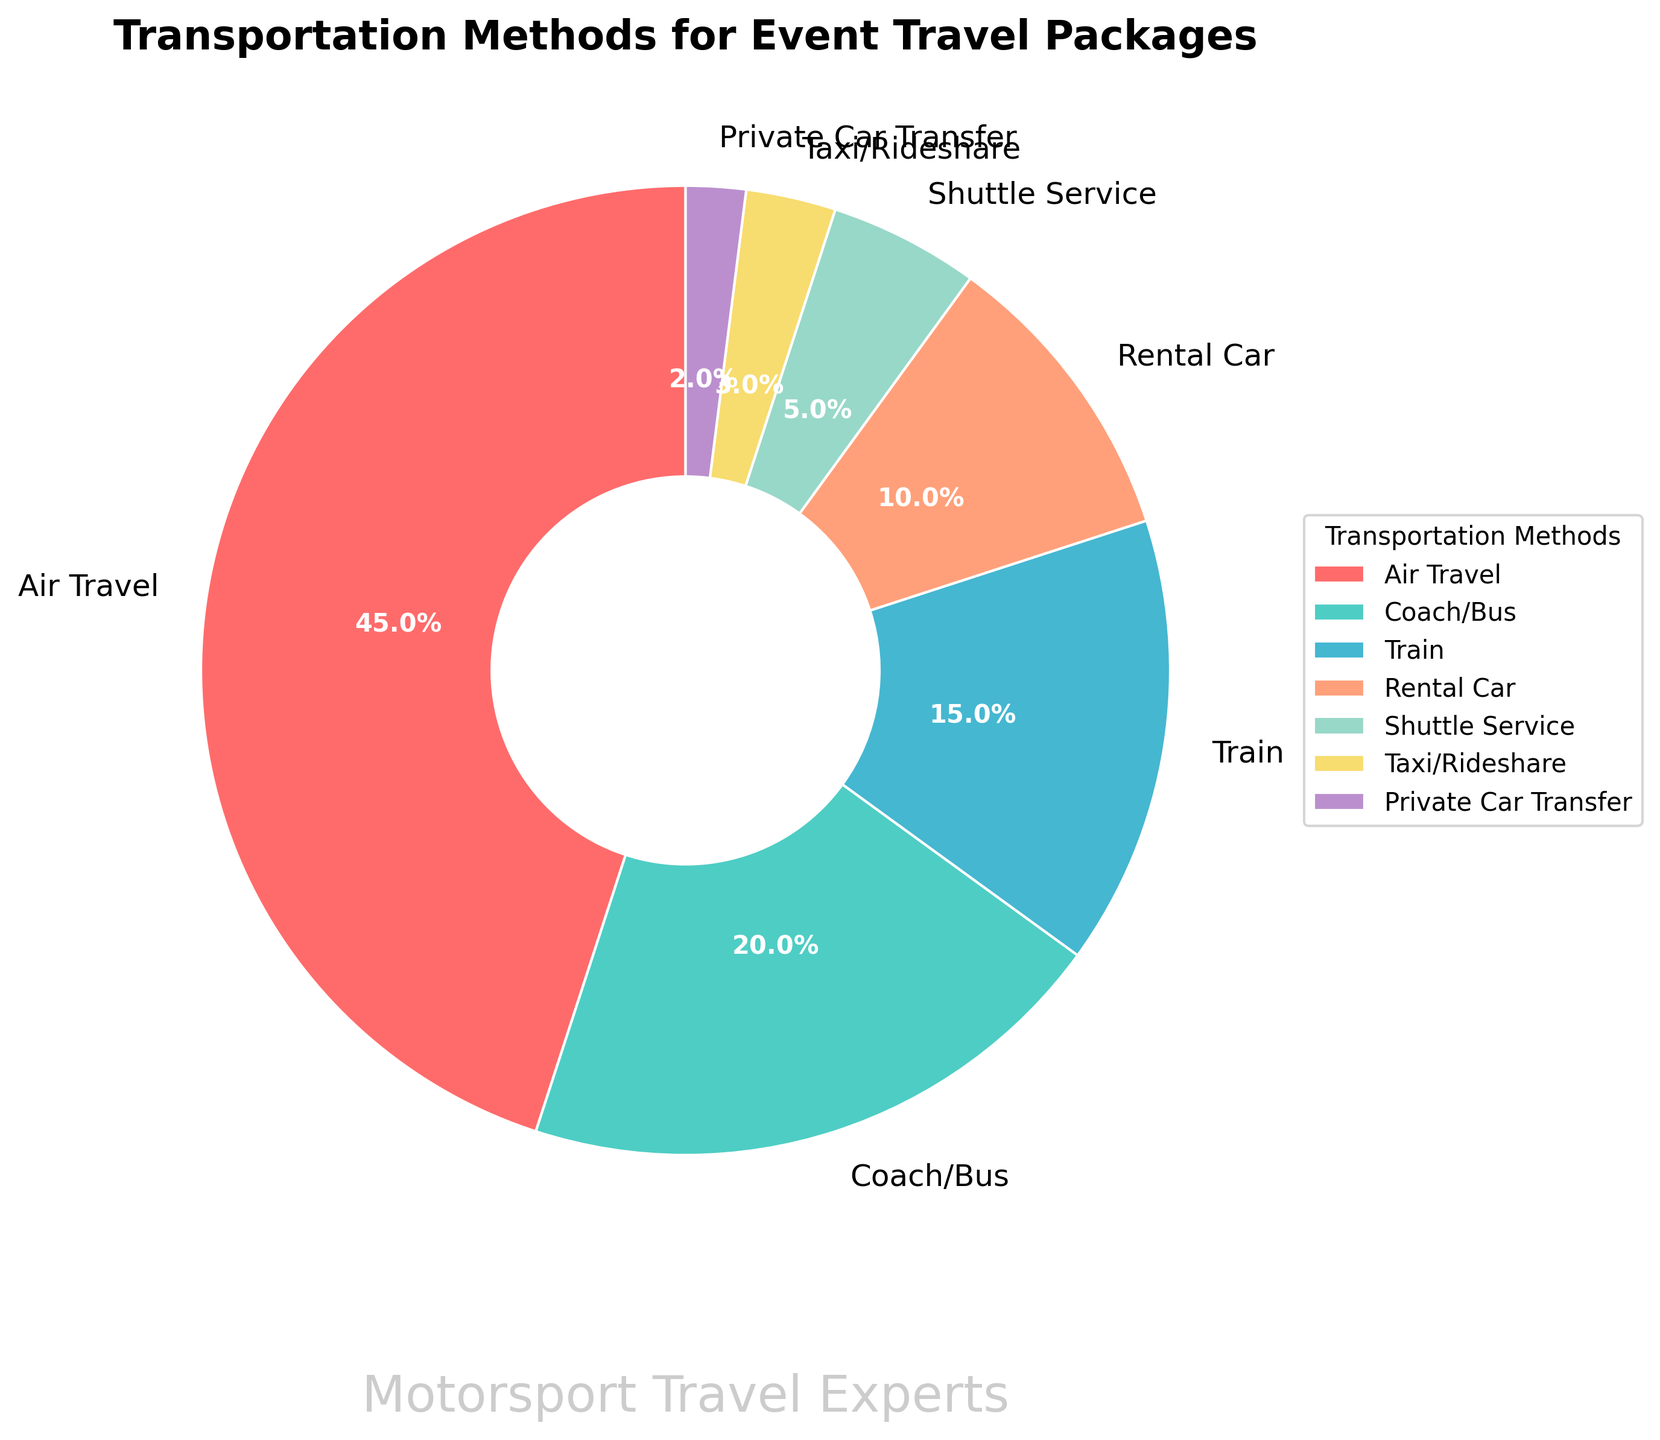Which transportation method is the most popular for event travel packages? By looking at the percentage shares, we can observe that "Air Travel" has the highest percentage, which is 45%.
Answer: Air Travel What percentage do Coach/Bus and Train add up to? Coach/Bus accounts for 20% and Train accounts for 15%. When combined, they total 20% + 15% = 35%.
Answer: 35% Is the percentage of Air Travel greater than the sum of Shuttle Service, Taxi/Rideshare, and Private Car Transfer? Air Travel is 45%. Shuttle Service is 5%, Taxi/Rideshare is 3%, and Private Car Transfer is 2%. Their sum is 5% + 3% + 2% = 10%. Since 45% is greater than 10%, the answer is yes.
Answer: Yes How much more popular is Air Travel compared to Rental Car? Air Travel is 45% and Rental Car is 10%. The difference is 45% - 10% = 35%.
Answer: 35% Which transportation method has the smallest share? Private Car Transfer has the smallest share with 2%.
Answer: Private Car Transfer How does the share of Coach/Bus compare with the share of Air Travel? Coach/Bus has a 20% share, while Air Travel has a 45% share. 45% is more than double 20%.
Answer: Air Travel is more than double Coach/Bus If we were to combine Rental Car and Shuttle Service, would their combined share surpass Train's share? Rental Car's share is 10% and Shuttle Service's share is 5%. Combined, 10% + 5% = 15%, which is equal to Train's share of 15%. Therefore, it does not surpass Train.
Answer: No What is the difference in percentage between Taxi/Rideshare and Private Car Transfer? Taxi/Rideshare has 3%, and Private Car Transfer has 2%. The difference is 3% - 2% = 1%.
Answer: 1% 